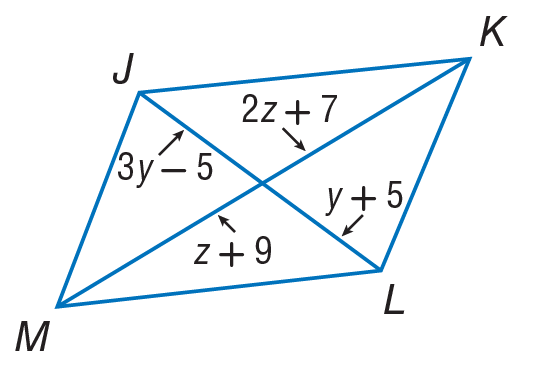Answer the mathemtical geometry problem and directly provide the correct option letter.
Question: Use parallelogram to find z.
Choices: A: 2 B: 7 C: 11 D: 13 A 